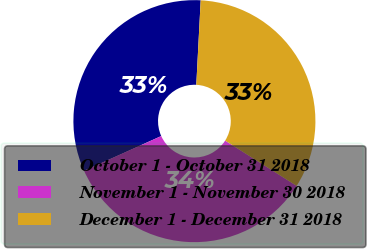Convert chart to OTSL. <chart><loc_0><loc_0><loc_500><loc_500><pie_chart><fcel>October 1 - October 31 2018<fcel>November 1 - November 30 2018<fcel>December 1 - December 31 2018<nl><fcel>32.56%<fcel>34.29%<fcel>33.16%<nl></chart> 